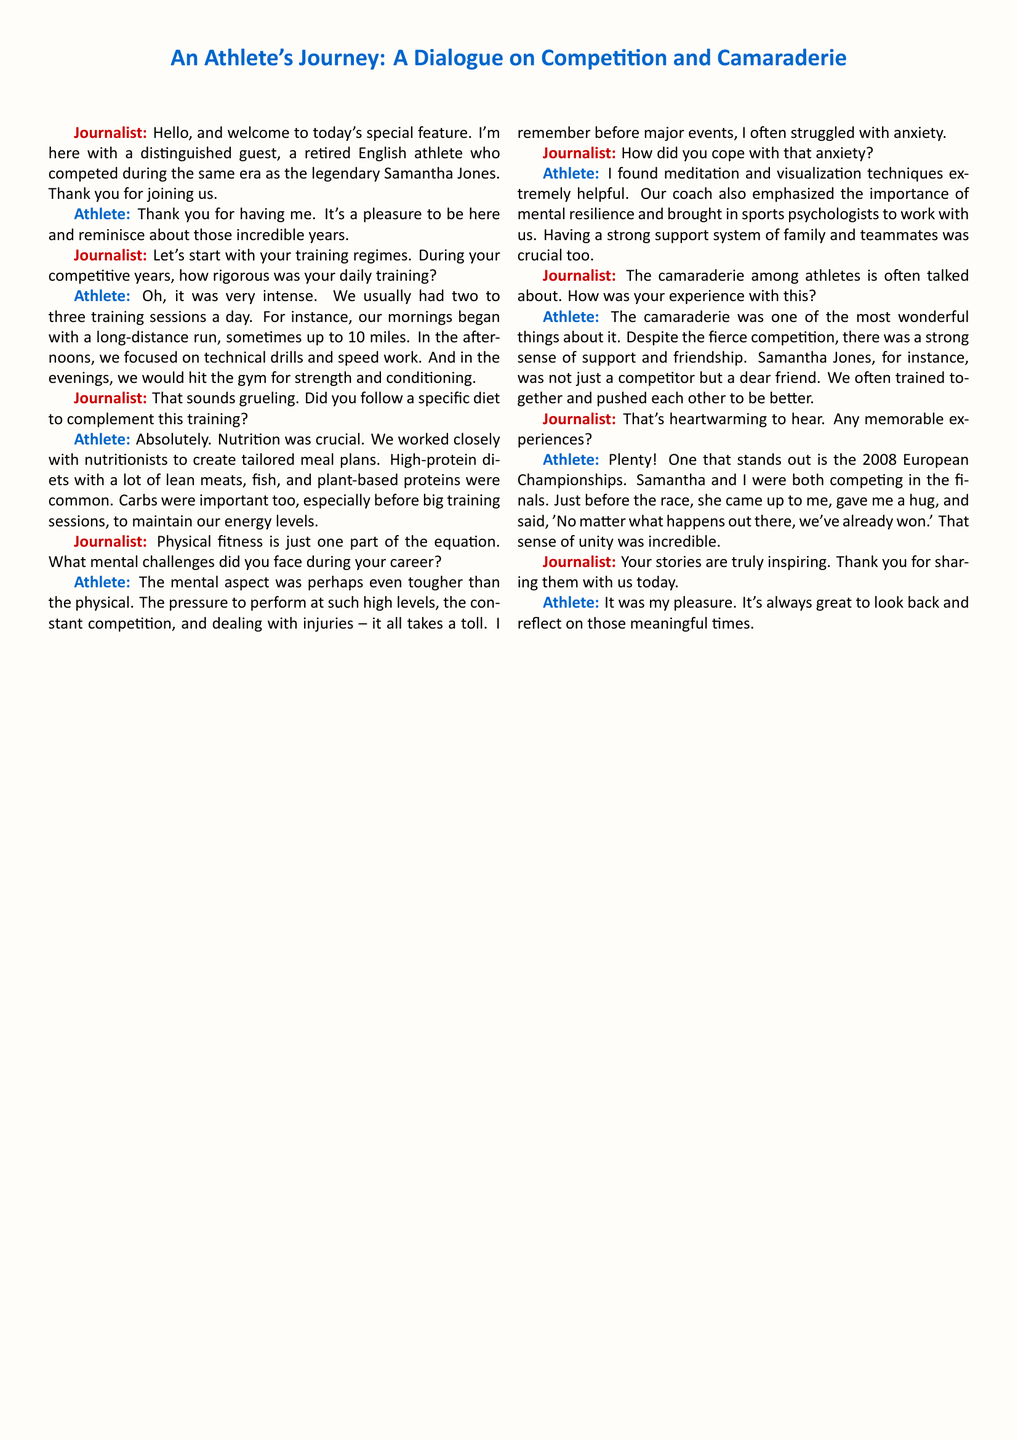What year did the athlete compete in the European Championships? The athlete mentions the 2008 European Championships specifically as a memorable event.
Answer: 2008 How many training sessions did the athlete typically have per day? The athlete states they usually had two to three training sessions a day.
Answer: Two to three What kind of relationship did the athlete have with Samantha Jones? The athlete describes Samantha as not just a competitor but a dear friend, indicating a close relationship.
Answer: Dear friend What techniques did the athlete use to cope with anxiety? The athlete found meditation and visualization techniques helpful in coping with anxiety.
Answer: Meditation and visualization What was crucial for the athlete's nutrition during training? The athlete emphasizes that working closely with nutritionists to create tailored meal plans was crucial.
Answer: Working with nutritionists What is described as one of the most wonderful aspects of being an athlete? The athlete notes that camaraderie, despite fierce competition, was a wonderful aspect of being an athlete.
Answer: Camaraderie Who emphasized the importance of mental resilience in training? The athlete mentions their coach emphasized the importance of mental resilience.
Answer: Coach What type of support was crucial for the athlete? The athlete highlights that having a strong support system of family and teammates was crucial.
Answer: Support system In which setting did the athlete mainly perform strength and conditioning? The athlete states that they would hit the gym for strength and conditioning.
Answer: Gym 